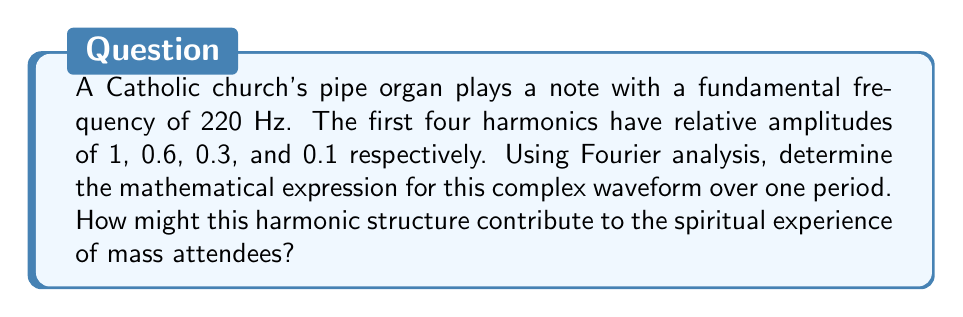Can you solve this math problem? To solve this problem, we'll use Fourier analysis to construct the waveform from its harmonics:

1) The fundamental frequency is $f_0 = 220$ Hz. The period is $T = \frac{1}{f_0} = \frac{1}{220}$ seconds.

2) The angular frequency is $\omega = 2\pi f_0 = 440\pi$ rad/s.

3) Each harmonic has a frequency that's an integer multiple of the fundamental:
   - 1st harmonic (fundamental): 220 Hz
   - 2nd harmonic: 440 Hz
   - 3rd harmonic: 660 Hz
   - 4th harmonic: 880 Hz

4) The Fourier series for this waveform can be expressed as:

   $$f(t) = A_1\sin(\omega t) + A_2\sin(2\omega t) + A_3\sin(3\omega t) + A_4\sin(4\omega t)$$

   where $A_1, A_2, A_3, A_4$ are the amplitudes of each harmonic.

5) Given the relative amplitudes, we can express this as:

   $$f(t) = A(\sin(\omega t) + 0.6\sin(2\omega t) + 0.3\sin(3\omega t) + 0.1\sin(4\omega t))$$

   where $A$ is the amplitude of the fundamental.

6) Substituting $\omega = 440\pi$, we get the final expression:

   $$f(t) = A(\sin(440\pi t) + 0.6\sin(880\pi t) + 0.3\sin(1320\pi t) + 0.1\sin(1760\pi t))$$

This harmonic structure contributes to the rich, complex sound of the organ, which has been traditionally associated with sacred music. The presence of harmonics gives the sound its characteristic timbre, often described as "full" or "majestic". This can enhance the spiritual experience of mass attendees by:

1) Creating a sense of awe and reverence through the rich, powerful sound.
2) Evoking emotional responses that may deepen religious feelings.
3) Providing a sonic environment conducive to contemplation and prayer.
4) Connecting the listener to centuries of Catholic musical tradition.

The harmonic structure, rooted in mathematical principles, can be seen as a reflection of divine order and complexity, potentially strengthening the faith of those who perceive this connection.
Answer: $$f(t) = A(\sin(440\pi t) + 0.6\sin(880\pi t) + 0.3\sin(1320\pi t) + 0.1\sin(1760\pi t))$$
where $A$ is the amplitude of the fundamental frequency and $t$ is time in seconds. 